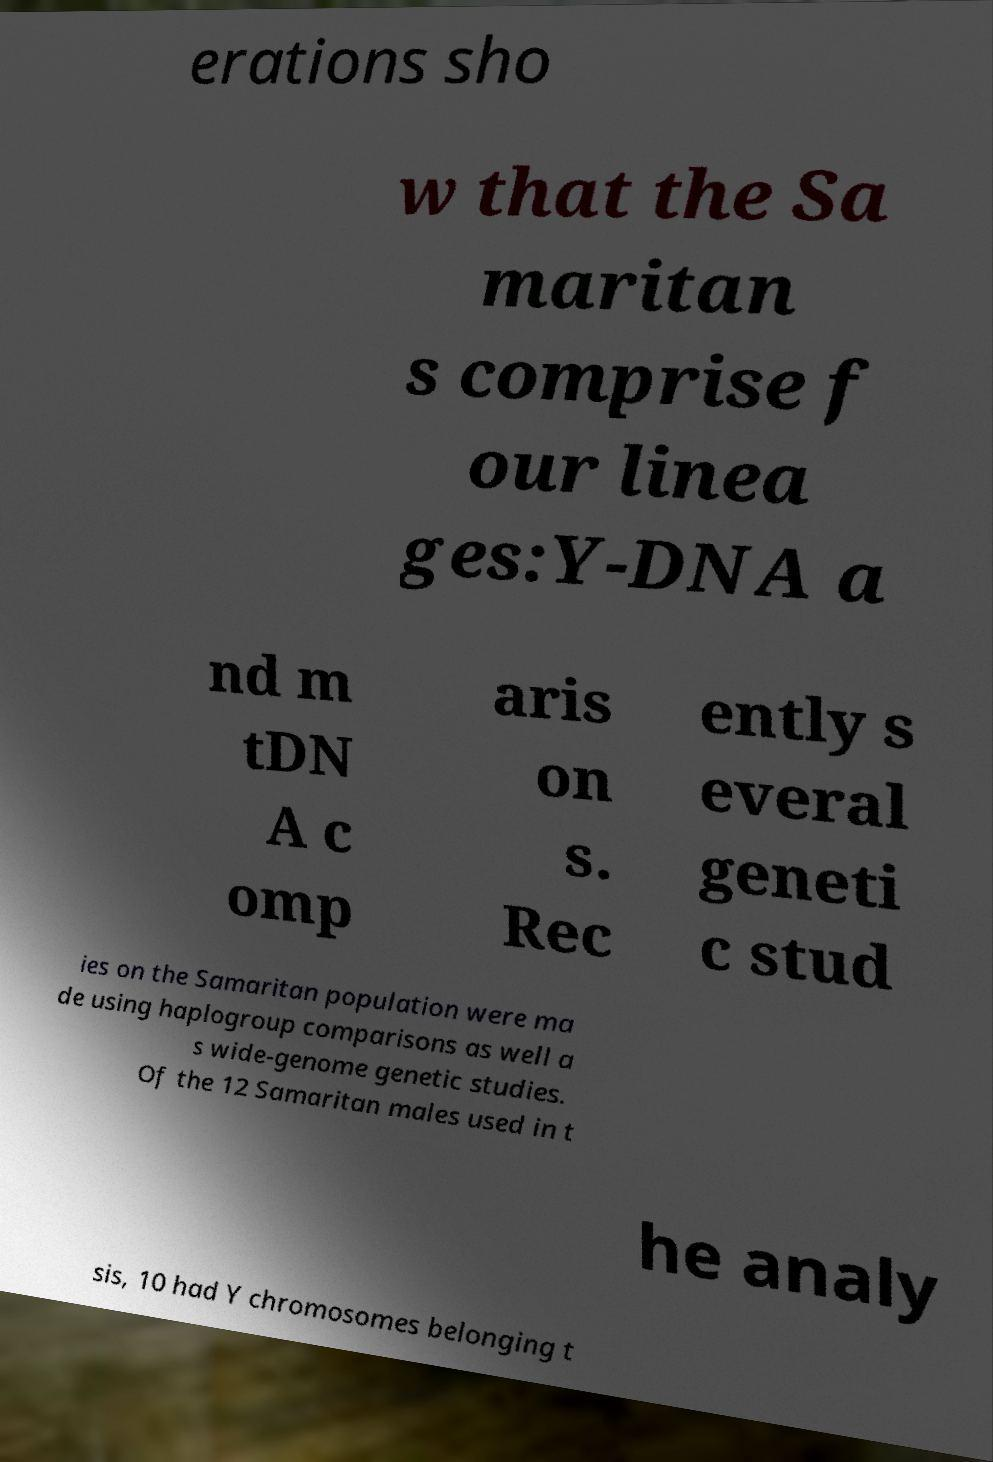Could you assist in decoding the text presented in this image and type it out clearly? erations sho w that the Sa maritan s comprise f our linea ges:Y-DNA a nd m tDN A c omp aris on s. Rec ently s everal geneti c stud ies on the Samaritan population were ma de using haplogroup comparisons as well a s wide-genome genetic studies. Of the 12 Samaritan males used in t he analy sis, 10 had Y chromosomes belonging t 